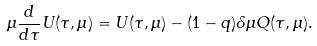Convert formula to latex. <formula><loc_0><loc_0><loc_500><loc_500>\mu \frac { d } { d \tau } U ( \tau , \mu ) = U ( \tau , \mu ) - ( 1 - q ) \delta \mu Q ( \tau , \mu ) .</formula> 